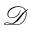Convert formula to latex. <formula><loc_0><loc_0><loc_500><loc_500>\mathcal { D }</formula> 